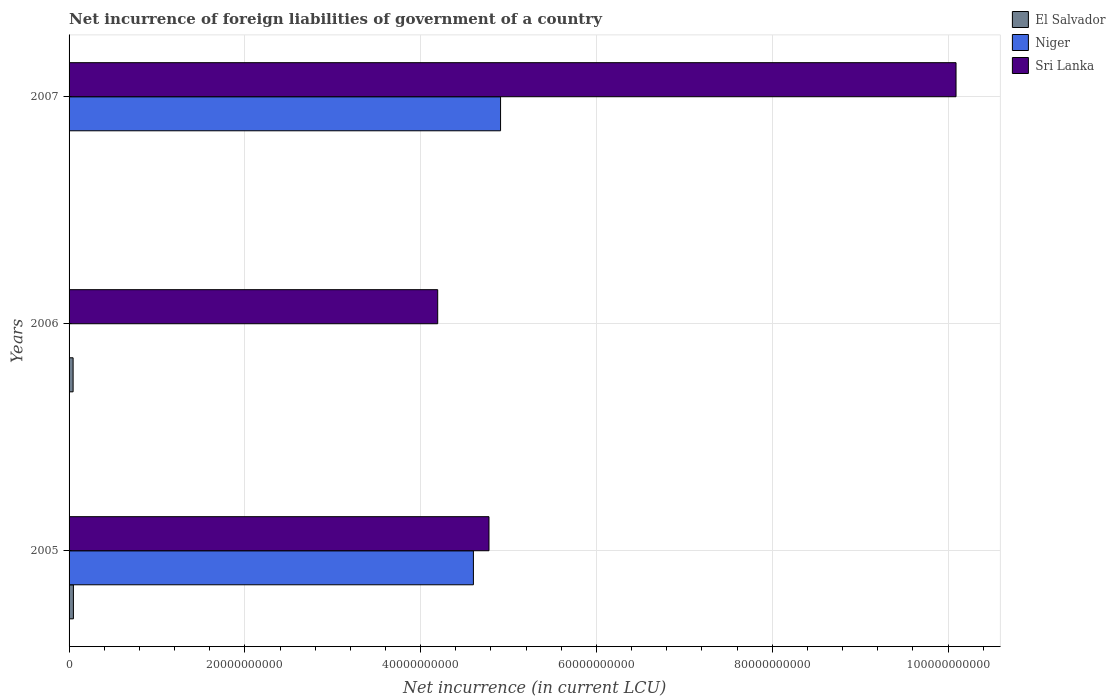How many different coloured bars are there?
Your answer should be compact. 3. Are the number of bars on each tick of the Y-axis equal?
Your response must be concise. No. What is the label of the 1st group of bars from the top?
Provide a short and direct response. 2007. In how many cases, is the number of bars for a given year not equal to the number of legend labels?
Your response must be concise. 2. What is the net incurrence of foreign liabilities in Niger in 2005?
Ensure brevity in your answer.  4.60e+1. Across all years, what is the maximum net incurrence of foreign liabilities in Niger?
Your response must be concise. 4.91e+1. What is the total net incurrence of foreign liabilities in Niger in the graph?
Make the answer very short. 9.51e+1. What is the difference between the net incurrence of foreign liabilities in Sri Lanka in 2005 and that in 2007?
Keep it short and to the point. -5.31e+1. What is the difference between the net incurrence of foreign liabilities in Sri Lanka in 2006 and the net incurrence of foreign liabilities in Niger in 2007?
Make the answer very short. -7.15e+09. What is the average net incurrence of foreign liabilities in El Salvador per year?
Your answer should be compact. 3.18e+08. In the year 2005, what is the difference between the net incurrence of foreign liabilities in El Salvador and net incurrence of foreign liabilities in Sri Lanka?
Ensure brevity in your answer.  -4.73e+1. What is the ratio of the net incurrence of foreign liabilities in El Salvador in 2005 to that in 2006?
Make the answer very short. 1.07. What is the difference between the highest and the second highest net incurrence of foreign liabilities in Sri Lanka?
Provide a short and direct response. 5.31e+1. What is the difference between the highest and the lowest net incurrence of foreign liabilities in Niger?
Keep it short and to the point. 4.91e+1. In how many years, is the net incurrence of foreign liabilities in El Salvador greater than the average net incurrence of foreign liabilities in El Salvador taken over all years?
Offer a very short reply. 2. Is the sum of the net incurrence of foreign liabilities in El Salvador in 2005 and 2006 greater than the maximum net incurrence of foreign liabilities in Sri Lanka across all years?
Provide a short and direct response. No. How many bars are there?
Ensure brevity in your answer.  7. Are all the bars in the graph horizontal?
Your answer should be compact. Yes. How many years are there in the graph?
Provide a succinct answer. 3. What is the difference between two consecutive major ticks on the X-axis?
Make the answer very short. 2.00e+1. Does the graph contain any zero values?
Give a very brief answer. Yes. Does the graph contain grids?
Provide a short and direct response. Yes. Where does the legend appear in the graph?
Offer a very short reply. Top right. How many legend labels are there?
Ensure brevity in your answer.  3. What is the title of the graph?
Your answer should be compact. Net incurrence of foreign liabilities of government of a country. What is the label or title of the X-axis?
Your response must be concise. Net incurrence (in current LCU). What is the Net incurrence (in current LCU) of El Salvador in 2005?
Ensure brevity in your answer.  4.94e+08. What is the Net incurrence (in current LCU) of Niger in 2005?
Offer a very short reply. 4.60e+1. What is the Net incurrence (in current LCU) in Sri Lanka in 2005?
Keep it short and to the point. 4.78e+1. What is the Net incurrence (in current LCU) in El Salvador in 2006?
Make the answer very short. 4.59e+08. What is the Net incurrence (in current LCU) in Sri Lanka in 2006?
Keep it short and to the point. 4.19e+1. What is the Net incurrence (in current LCU) of Niger in 2007?
Provide a succinct answer. 4.91e+1. What is the Net incurrence (in current LCU) in Sri Lanka in 2007?
Your answer should be very brief. 1.01e+11. Across all years, what is the maximum Net incurrence (in current LCU) in El Salvador?
Provide a short and direct response. 4.94e+08. Across all years, what is the maximum Net incurrence (in current LCU) in Niger?
Keep it short and to the point. 4.91e+1. Across all years, what is the maximum Net incurrence (in current LCU) in Sri Lanka?
Offer a very short reply. 1.01e+11. Across all years, what is the minimum Net incurrence (in current LCU) in Sri Lanka?
Offer a very short reply. 4.19e+1. What is the total Net incurrence (in current LCU) of El Salvador in the graph?
Your answer should be compact. 9.53e+08. What is the total Net incurrence (in current LCU) of Niger in the graph?
Your answer should be very brief. 9.51e+1. What is the total Net incurrence (in current LCU) in Sri Lanka in the graph?
Offer a terse response. 1.91e+11. What is the difference between the Net incurrence (in current LCU) of El Salvador in 2005 and that in 2006?
Offer a very short reply. 3.42e+07. What is the difference between the Net incurrence (in current LCU) of Sri Lanka in 2005 and that in 2006?
Make the answer very short. 5.83e+09. What is the difference between the Net incurrence (in current LCU) of Niger in 2005 and that in 2007?
Your response must be concise. -3.09e+09. What is the difference between the Net incurrence (in current LCU) of Sri Lanka in 2005 and that in 2007?
Provide a short and direct response. -5.31e+1. What is the difference between the Net incurrence (in current LCU) of Sri Lanka in 2006 and that in 2007?
Make the answer very short. -5.90e+1. What is the difference between the Net incurrence (in current LCU) of El Salvador in 2005 and the Net incurrence (in current LCU) of Sri Lanka in 2006?
Ensure brevity in your answer.  -4.14e+1. What is the difference between the Net incurrence (in current LCU) of Niger in 2005 and the Net incurrence (in current LCU) of Sri Lanka in 2006?
Make the answer very short. 4.06e+09. What is the difference between the Net incurrence (in current LCU) in El Salvador in 2005 and the Net incurrence (in current LCU) in Niger in 2007?
Give a very brief answer. -4.86e+1. What is the difference between the Net incurrence (in current LCU) of El Salvador in 2005 and the Net incurrence (in current LCU) of Sri Lanka in 2007?
Ensure brevity in your answer.  -1.00e+11. What is the difference between the Net incurrence (in current LCU) of Niger in 2005 and the Net incurrence (in current LCU) of Sri Lanka in 2007?
Provide a short and direct response. -5.49e+1. What is the difference between the Net incurrence (in current LCU) in El Salvador in 2006 and the Net incurrence (in current LCU) in Niger in 2007?
Give a very brief answer. -4.86e+1. What is the difference between the Net incurrence (in current LCU) in El Salvador in 2006 and the Net incurrence (in current LCU) in Sri Lanka in 2007?
Keep it short and to the point. -1.00e+11. What is the average Net incurrence (in current LCU) of El Salvador per year?
Ensure brevity in your answer.  3.18e+08. What is the average Net incurrence (in current LCU) in Niger per year?
Offer a terse response. 3.17e+1. What is the average Net incurrence (in current LCU) of Sri Lanka per year?
Provide a succinct answer. 6.35e+1. In the year 2005, what is the difference between the Net incurrence (in current LCU) of El Salvador and Net incurrence (in current LCU) of Niger?
Offer a terse response. -4.55e+1. In the year 2005, what is the difference between the Net incurrence (in current LCU) of El Salvador and Net incurrence (in current LCU) of Sri Lanka?
Offer a very short reply. -4.73e+1. In the year 2005, what is the difference between the Net incurrence (in current LCU) of Niger and Net incurrence (in current LCU) of Sri Lanka?
Your answer should be very brief. -1.77e+09. In the year 2006, what is the difference between the Net incurrence (in current LCU) in El Salvador and Net incurrence (in current LCU) in Sri Lanka?
Your answer should be compact. -4.15e+1. In the year 2007, what is the difference between the Net incurrence (in current LCU) in Niger and Net incurrence (in current LCU) in Sri Lanka?
Your answer should be very brief. -5.18e+1. What is the ratio of the Net incurrence (in current LCU) of El Salvador in 2005 to that in 2006?
Provide a short and direct response. 1.07. What is the ratio of the Net incurrence (in current LCU) in Sri Lanka in 2005 to that in 2006?
Your answer should be very brief. 1.14. What is the ratio of the Net incurrence (in current LCU) of Niger in 2005 to that in 2007?
Provide a succinct answer. 0.94. What is the ratio of the Net incurrence (in current LCU) of Sri Lanka in 2005 to that in 2007?
Give a very brief answer. 0.47. What is the ratio of the Net incurrence (in current LCU) of Sri Lanka in 2006 to that in 2007?
Your answer should be very brief. 0.42. What is the difference between the highest and the second highest Net incurrence (in current LCU) of Sri Lanka?
Provide a short and direct response. 5.31e+1. What is the difference between the highest and the lowest Net incurrence (in current LCU) of El Salvador?
Offer a very short reply. 4.94e+08. What is the difference between the highest and the lowest Net incurrence (in current LCU) in Niger?
Make the answer very short. 4.91e+1. What is the difference between the highest and the lowest Net incurrence (in current LCU) of Sri Lanka?
Make the answer very short. 5.90e+1. 